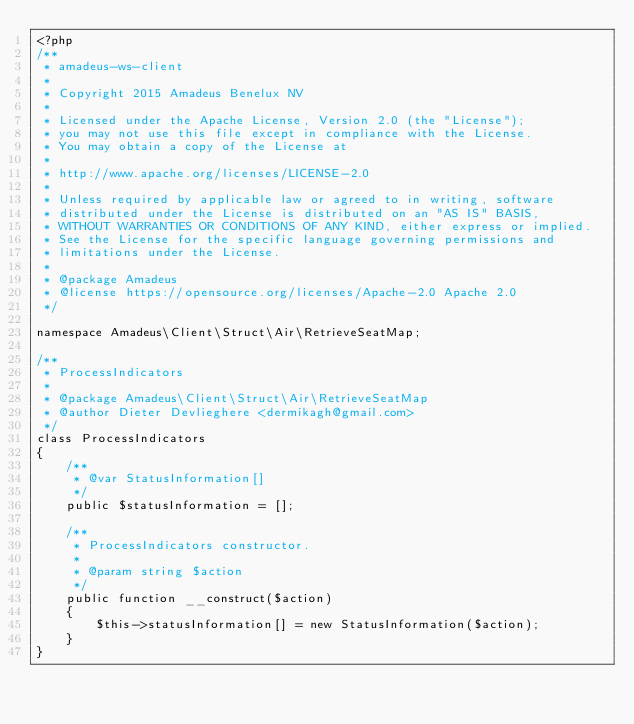<code> <loc_0><loc_0><loc_500><loc_500><_PHP_><?php
/**
 * amadeus-ws-client
 *
 * Copyright 2015 Amadeus Benelux NV
 *
 * Licensed under the Apache License, Version 2.0 (the "License");
 * you may not use this file except in compliance with the License.
 * You may obtain a copy of the License at
 *
 * http://www.apache.org/licenses/LICENSE-2.0
 *
 * Unless required by applicable law or agreed to in writing, software
 * distributed under the License is distributed on an "AS IS" BASIS,
 * WITHOUT WARRANTIES OR CONDITIONS OF ANY KIND, either express or implied.
 * See the License for the specific language governing permissions and
 * limitations under the License.
 *
 * @package Amadeus
 * @license https://opensource.org/licenses/Apache-2.0 Apache 2.0
 */

namespace Amadeus\Client\Struct\Air\RetrieveSeatMap;

/**
 * ProcessIndicators
 *
 * @package Amadeus\Client\Struct\Air\RetrieveSeatMap
 * @author Dieter Devlieghere <dermikagh@gmail.com>
 */
class ProcessIndicators
{
    /**
     * @var StatusInformation[]
     */
    public $statusInformation = [];

    /**
     * ProcessIndicators constructor.
     *
     * @param string $action
     */
    public function __construct($action)
    {
        $this->statusInformation[] = new StatusInformation($action);
    }
}
</code> 